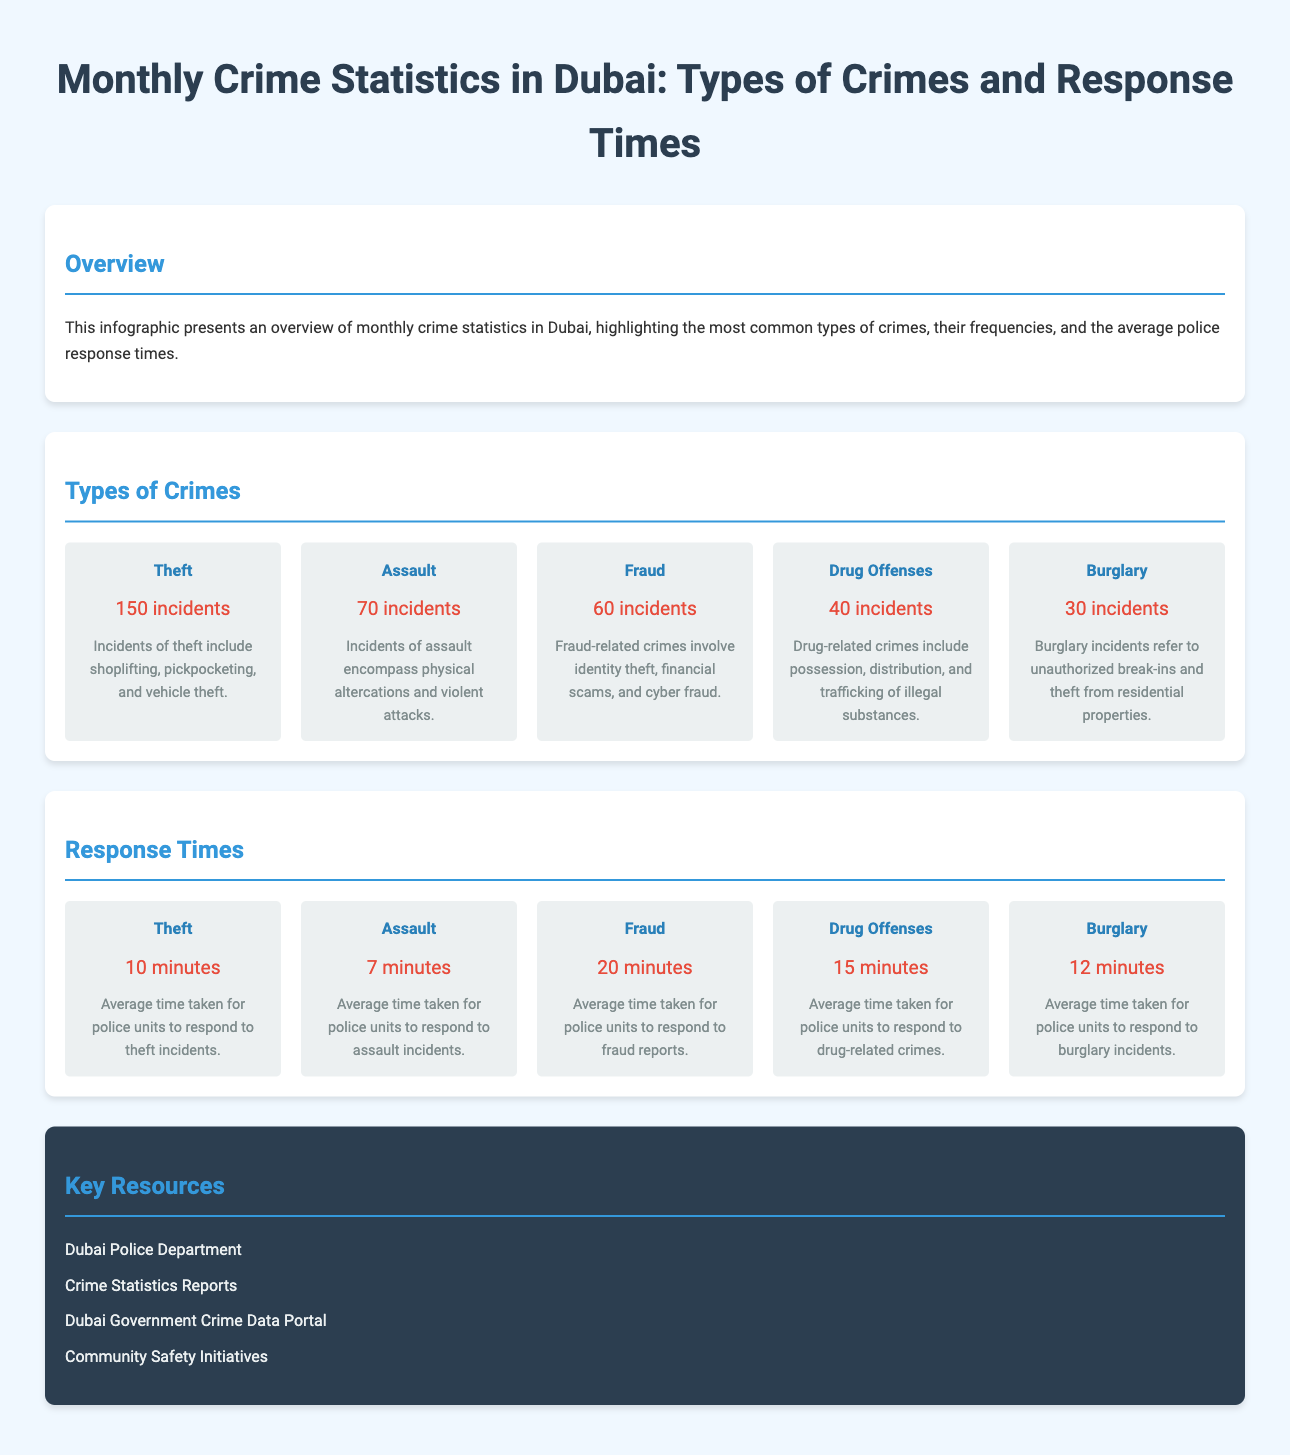What was the frequency of theft incidents? The frequency of theft incidents is provided in the document, which states there were 150 incidents of theft.
Answer: 150 incidents How many incidents of drug offenses were reported? The document lists the number of incidents related to drug offenses, which is given as 40 incidents.
Answer: 40 incidents What is the average response time for assault incidents? The average response time for assault incidents is specified in the document as 7 minutes.
Answer: 7 minutes Which type of crime had the highest number of incidents? The infographic shows that the type of crime with the highest number of incidents is theft, with 150 incidents.
Answer: Theft What is the average police response time for fraud? The document indicates that the average police response time for fraud is 20 minutes.
Answer: 20 minutes How many types of crimes are listed in the document? The infographic contains details on five different types of crimes.
Answer: Five types Which crime type had the longest response time? By analyzing the response times provided, fraud has the longest response time at 20 minutes.
Answer: Fraud How many incidents of burglary were reported? The number of burglary incidents is detailed in the document, which reports 30 incidents.
Answer: 30 incidents 